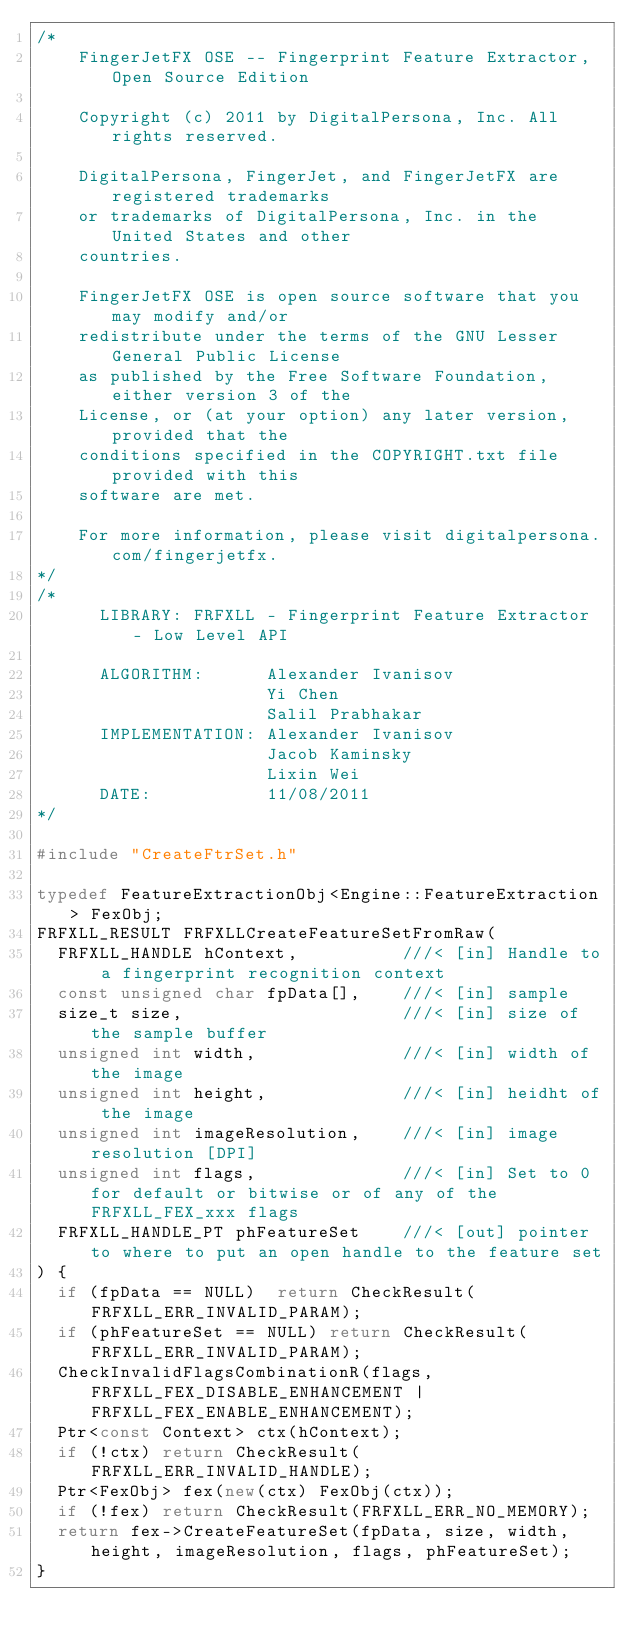<code> <loc_0><loc_0><loc_500><loc_500><_C++_>/*
    FingerJetFX OSE -- Fingerprint Feature Extractor, Open Source Edition

    Copyright (c) 2011 by DigitalPersona, Inc. All rights reserved.

    DigitalPersona, FingerJet, and FingerJetFX are registered trademarks 
    or trademarks of DigitalPersona, Inc. in the United States and other
    countries.

    FingerJetFX OSE is open source software that you may modify and/or
    redistribute under the terms of the GNU Lesser General Public License
    as published by the Free Software Foundation, either version 3 of the 
    License, or (at your option) any later version, provided that the 
    conditions specified in the COPYRIGHT.txt file provided with this 
    software are met.
 
    For more information, please visit digitalpersona.com/fingerjetfx.
*/ 
/*
      LIBRARY: FRFXLL - Fingerprint Feature Extractor - Low Level API

      ALGORITHM:      Alexander Ivanisov
                      Yi Chen
                      Salil Prabhakar
      IMPLEMENTATION: Alexander Ivanisov
                      Jacob Kaminsky
                      Lixin Wei
      DATE:           11/08/2011
*/

#include "CreateFtrSet.h"

typedef FeatureExtractionObj<Engine::FeatureExtraction> FexObj;
FRFXLL_RESULT FRFXLLCreateFeatureSetFromRaw(
  FRFXLL_HANDLE hContext,          ///< [in] Handle to a fingerprint recognition context
  const unsigned char fpData[],    ///< [in] sample
  size_t size,                     ///< [in] size of the sample buffer
  unsigned int width,              ///< [in] width of the image
  unsigned int height,             ///< [in] heidht of the image
  unsigned int imageResolution,    ///< [in] image resolution [DPI]
  unsigned int flags,              ///< [in] Set to 0 for default or bitwise or of any of the FRFXLL_FEX_xxx flags
  FRFXLL_HANDLE_PT phFeatureSet    ///< [out] pointer to where to put an open handle to the feature set
) {
  if (fpData == NULL)  return CheckResult(FRFXLL_ERR_INVALID_PARAM);
  if (phFeatureSet == NULL) return CheckResult(FRFXLL_ERR_INVALID_PARAM);
  CheckInvalidFlagsCombinationR(flags, FRFXLL_FEX_DISABLE_ENHANCEMENT | FRFXLL_FEX_ENABLE_ENHANCEMENT);
  Ptr<const Context> ctx(hContext);
  if (!ctx) return CheckResult(FRFXLL_ERR_INVALID_HANDLE);
  Ptr<FexObj> fex(new(ctx) FexObj(ctx));
  if (!fex) return CheckResult(FRFXLL_ERR_NO_MEMORY);
  return fex->CreateFeatureSet(fpData, size, width, height, imageResolution, flags, phFeatureSet);
}
</code> 